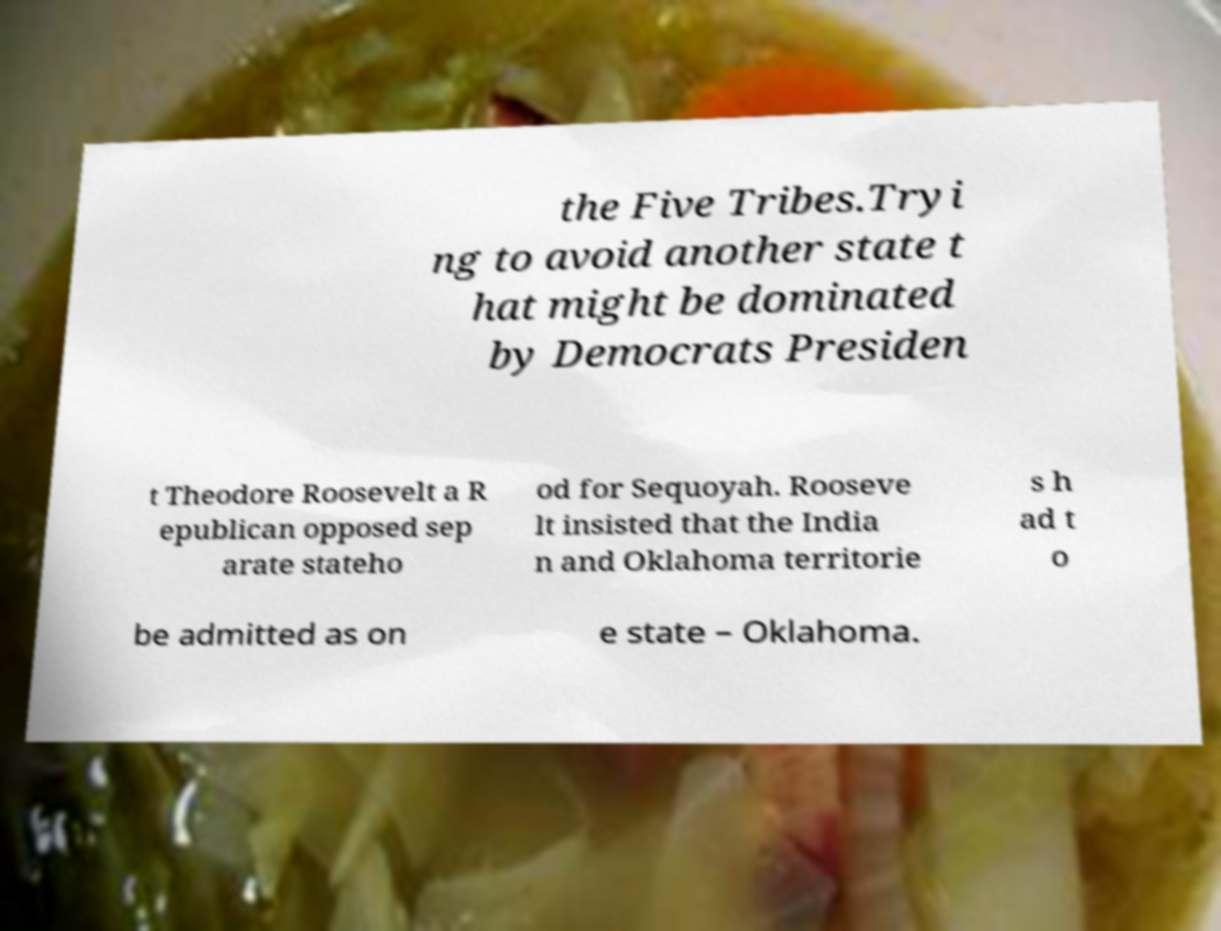There's text embedded in this image that I need extracted. Can you transcribe it verbatim? the Five Tribes.Tryi ng to avoid another state t hat might be dominated by Democrats Presiden t Theodore Roosevelt a R epublican opposed sep arate stateho od for Sequoyah. Rooseve lt insisted that the India n and Oklahoma territorie s h ad t o be admitted as on e state – Oklahoma. 